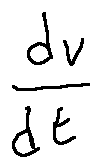Convert formula to latex. <formula><loc_0><loc_0><loc_500><loc_500>\frac { d v } { d t }</formula> 